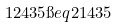<formula> <loc_0><loc_0><loc_500><loc_500>1 2 4 3 5 \i e q 2 1 4 3 5</formula> 